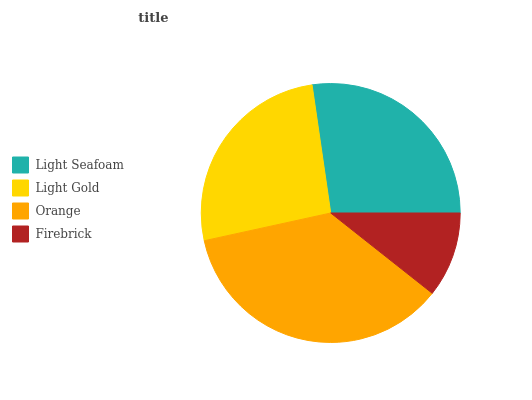Is Firebrick the minimum?
Answer yes or no. Yes. Is Orange the maximum?
Answer yes or no. Yes. Is Light Gold the minimum?
Answer yes or no. No. Is Light Gold the maximum?
Answer yes or no. No. Is Light Seafoam greater than Light Gold?
Answer yes or no. Yes. Is Light Gold less than Light Seafoam?
Answer yes or no. Yes. Is Light Gold greater than Light Seafoam?
Answer yes or no. No. Is Light Seafoam less than Light Gold?
Answer yes or no. No. Is Light Seafoam the high median?
Answer yes or no. Yes. Is Light Gold the low median?
Answer yes or no. Yes. Is Orange the high median?
Answer yes or no. No. Is Light Seafoam the low median?
Answer yes or no. No. 